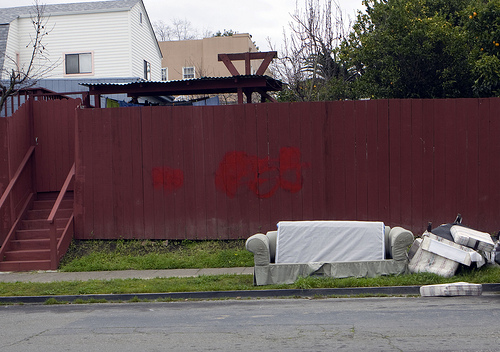<image>
Is there a stairs behind the house? No. The stairs is not behind the house. From this viewpoint, the stairs appears to be positioned elsewhere in the scene. 